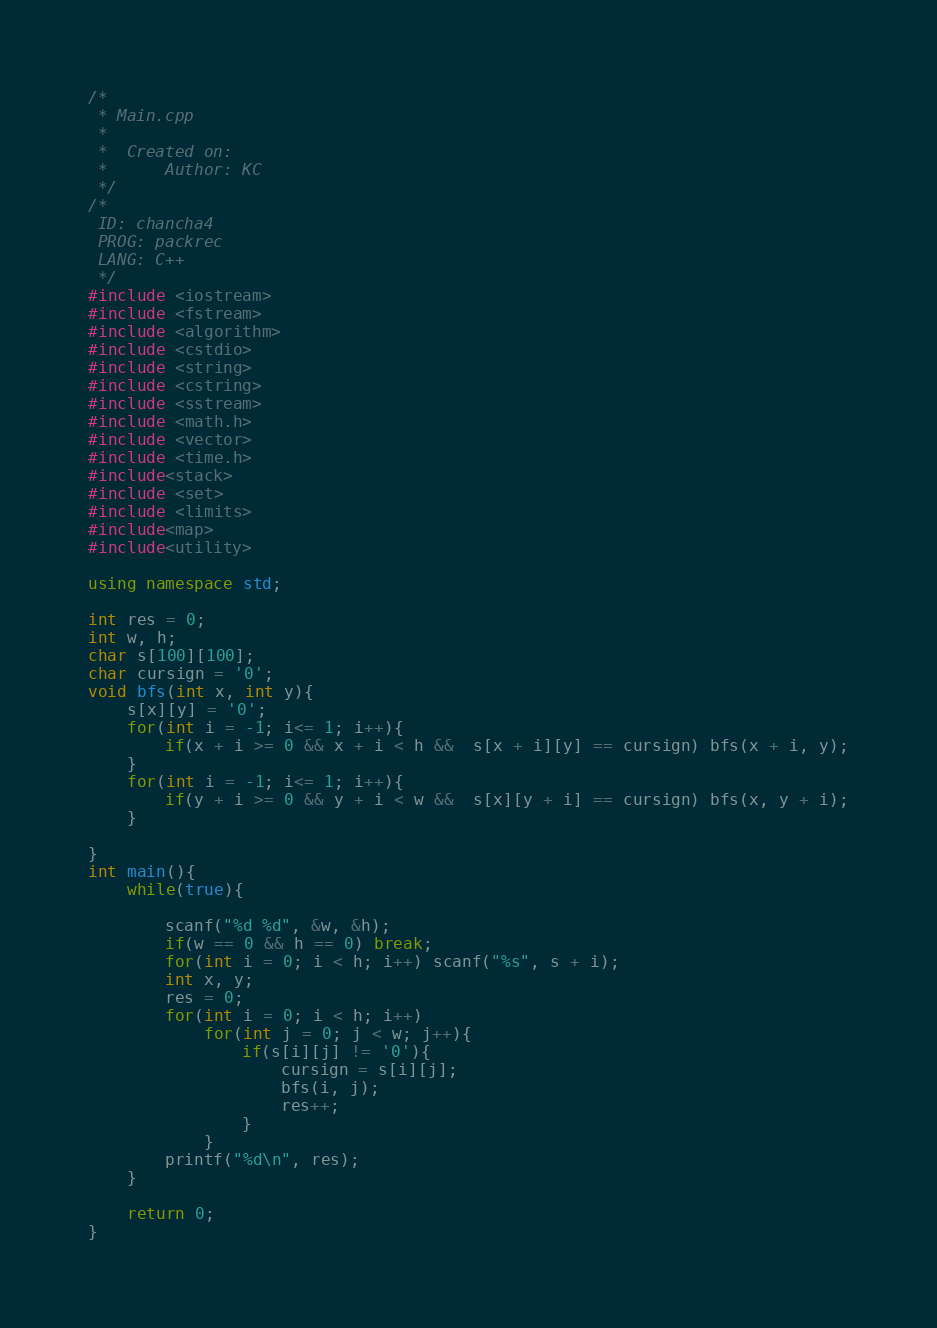<code> <loc_0><loc_0><loc_500><loc_500><_C++_>/*
 * Main.cpp
 *
 *  Created on:
 *      Author: KC
 */
/*
 ID: chancha4
 PROG: packrec
 LANG: C++
 */
#include <iostream>
#include <fstream>
#include <algorithm>
#include <cstdio>
#include <string>
#include <cstring>
#include <sstream>
#include <math.h>
#include <vector>
#include <time.h>
#include<stack>
#include <set>
#include <limits>
#include<map>
#include<utility>

using namespace std;

int res = 0;
int w, h;
char s[100][100];
char cursign = '0';
void bfs(int x, int y){
    s[x][y] = '0';
    for(int i = -1; i<= 1; i++){
        if(x + i >= 0 && x + i < h &&  s[x + i][y] == cursign) bfs(x + i, y);
    }
    for(int i = -1; i<= 1; i++){
        if(y + i >= 0 && y + i < w &&  s[x][y + i] == cursign) bfs(x, y + i);
    }

}
int main(){
    while(true){

        scanf("%d %d", &w, &h);
        if(w == 0 && h == 0) break;
        for(int i = 0; i < h; i++) scanf("%s", s + i);
        int x, y;
        res = 0;
        for(int i = 0; i < h; i++)
            for(int j = 0; j < w; j++){
                if(s[i][j] != '0'){
                    cursign = s[i][j];
                    bfs(i, j);
                    res++;
                }
            }
        printf("%d\n", res);
    }

    return 0;
}</code> 